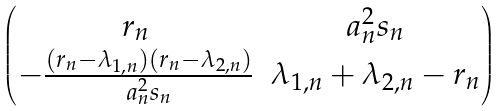<formula> <loc_0><loc_0><loc_500><loc_500>\begin{pmatrix} r _ { n } & a _ { n } ^ { 2 } s _ { n } \\ - \frac { \left ( r _ { n } - \lambda _ { 1 , n } \right ) \left ( r _ { n } - \lambda _ { 2 , n } \right ) } { a _ { n } ^ { 2 } s _ { n } } & \lambda _ { 1 , n } + \lambda _ { 2 , n } - r _ { n } \end{pmatrix}</formula> 